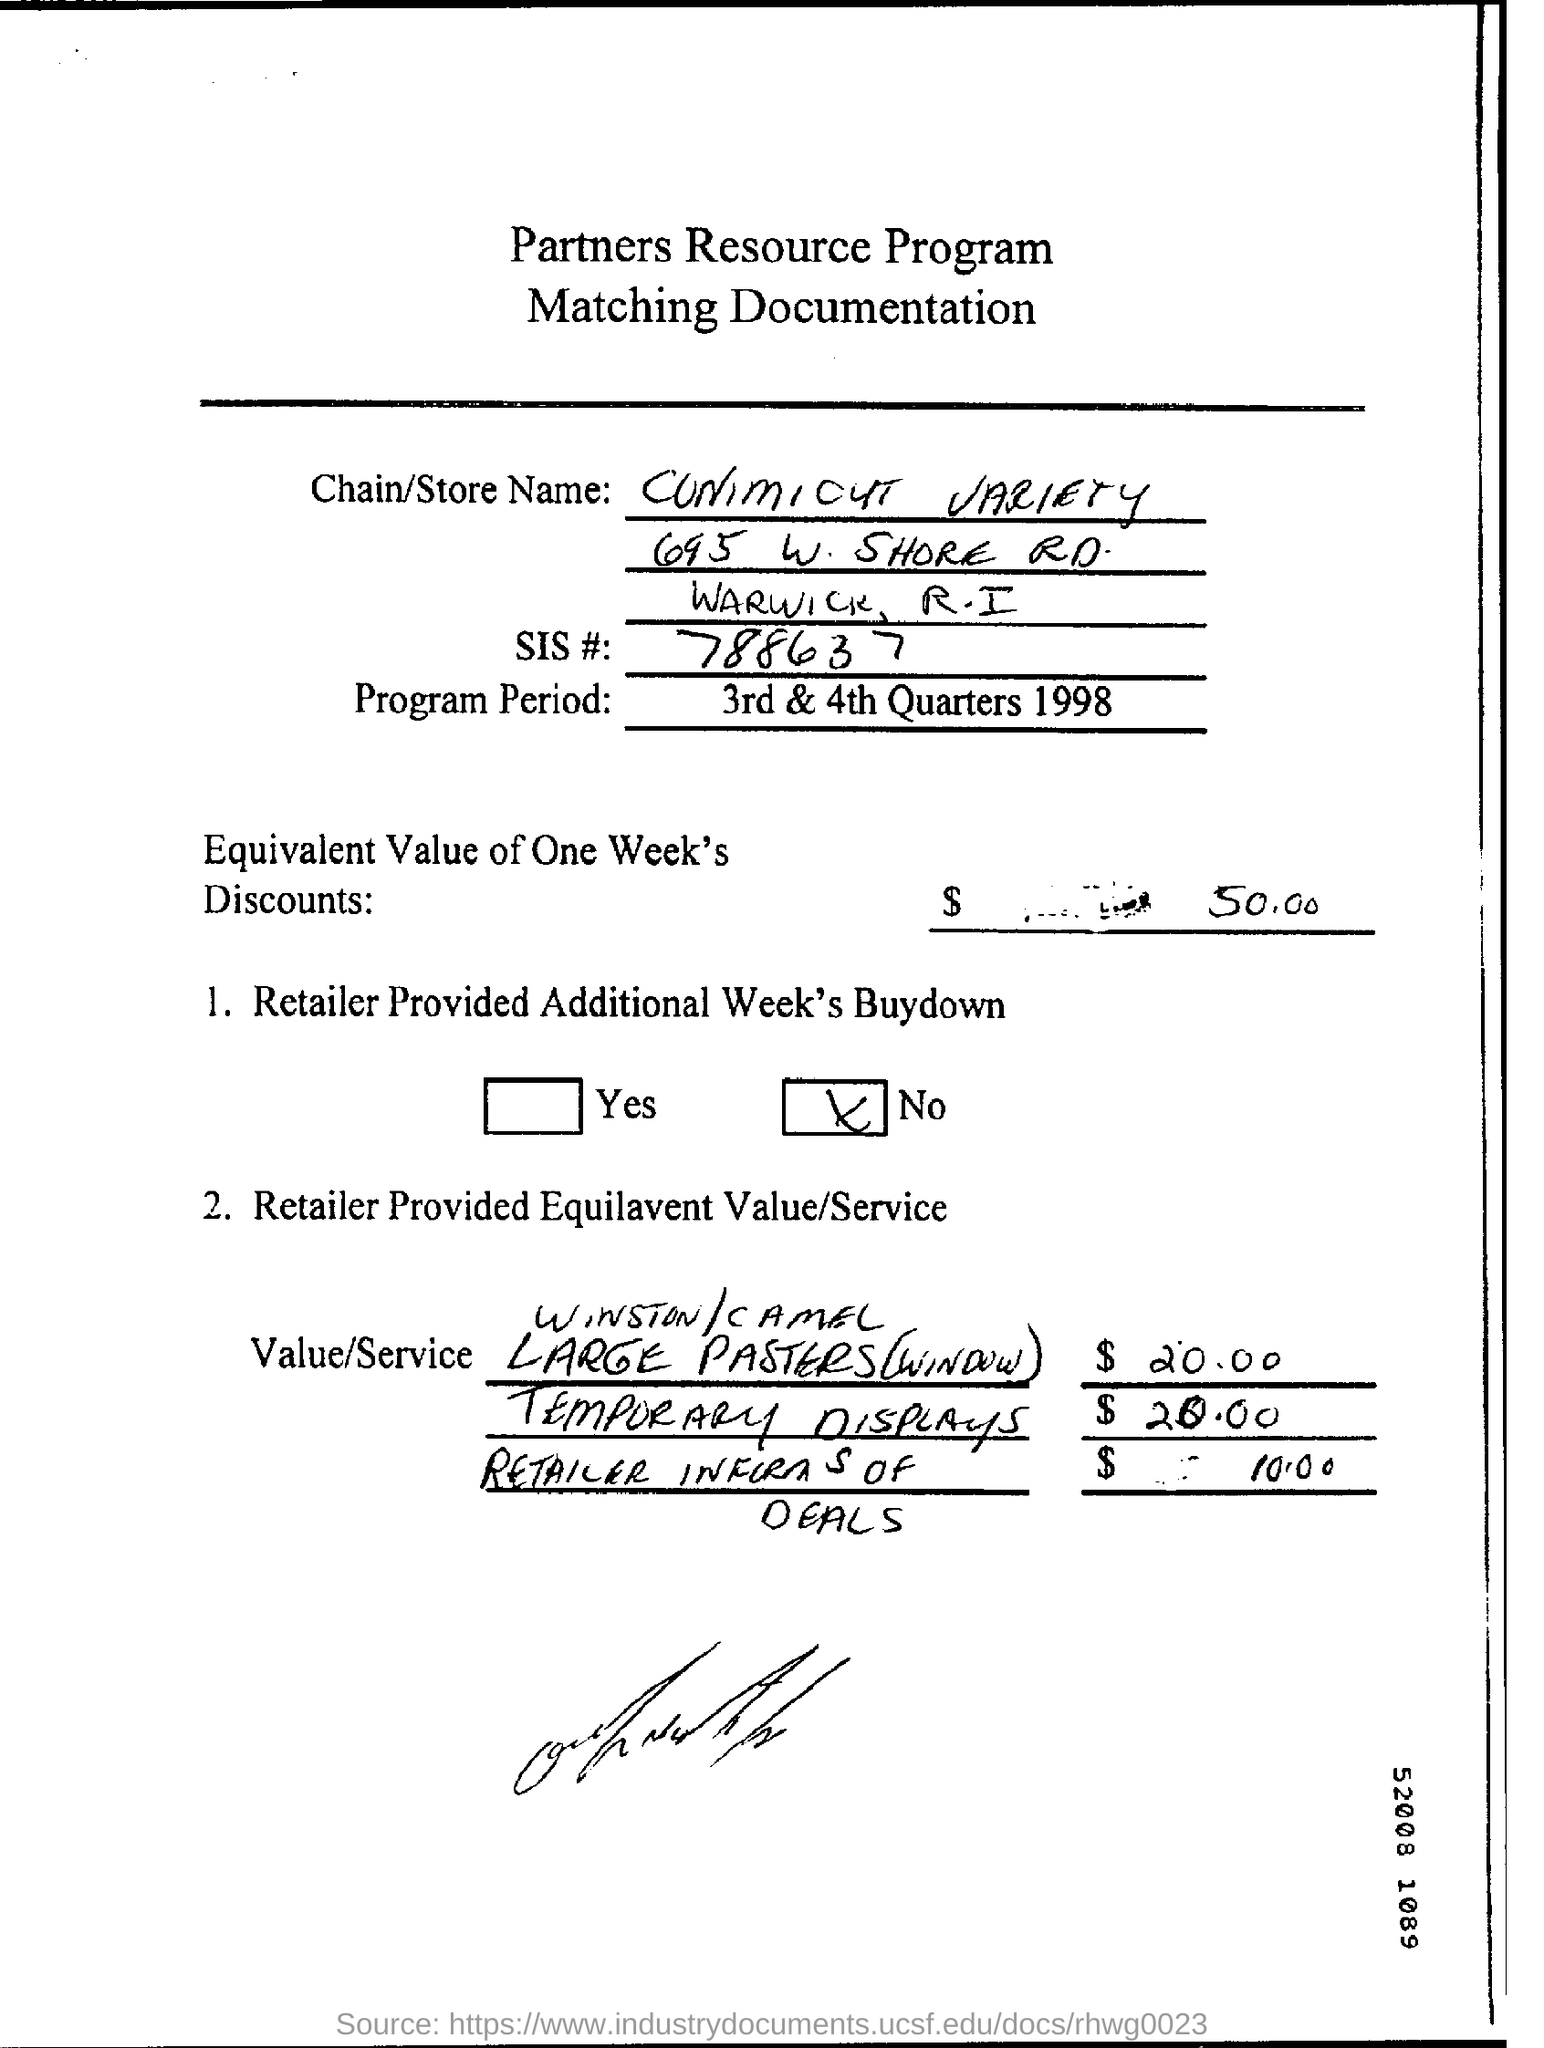Identify some key points in this picture. The document titled "What is the Title of the document? Partners Resource Program Matching Documentation..." is a declaration that provides information about a program related to partnerships and resources. The SIS number is 788637... 